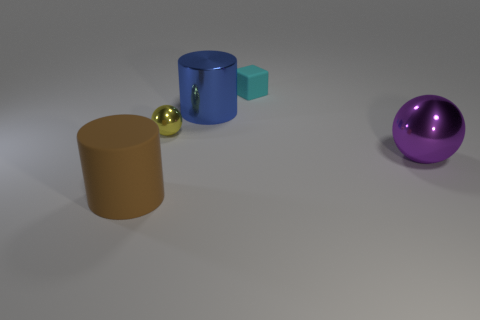Is the material of the big cylinder to the left of the blue object the same as the ball to the left of the blue metal cylinder? Upon examining the scene, it's clear that the big cylinder to the left of the blue object, which is brown and appears to have a rubbery texture, has a different material composition compared to the ball left of the blue metal cylinder. The latter, a metallic purple sphere, reflects light differently indicating it is metallic. Thus, these objects are made from distinctly different materials. 